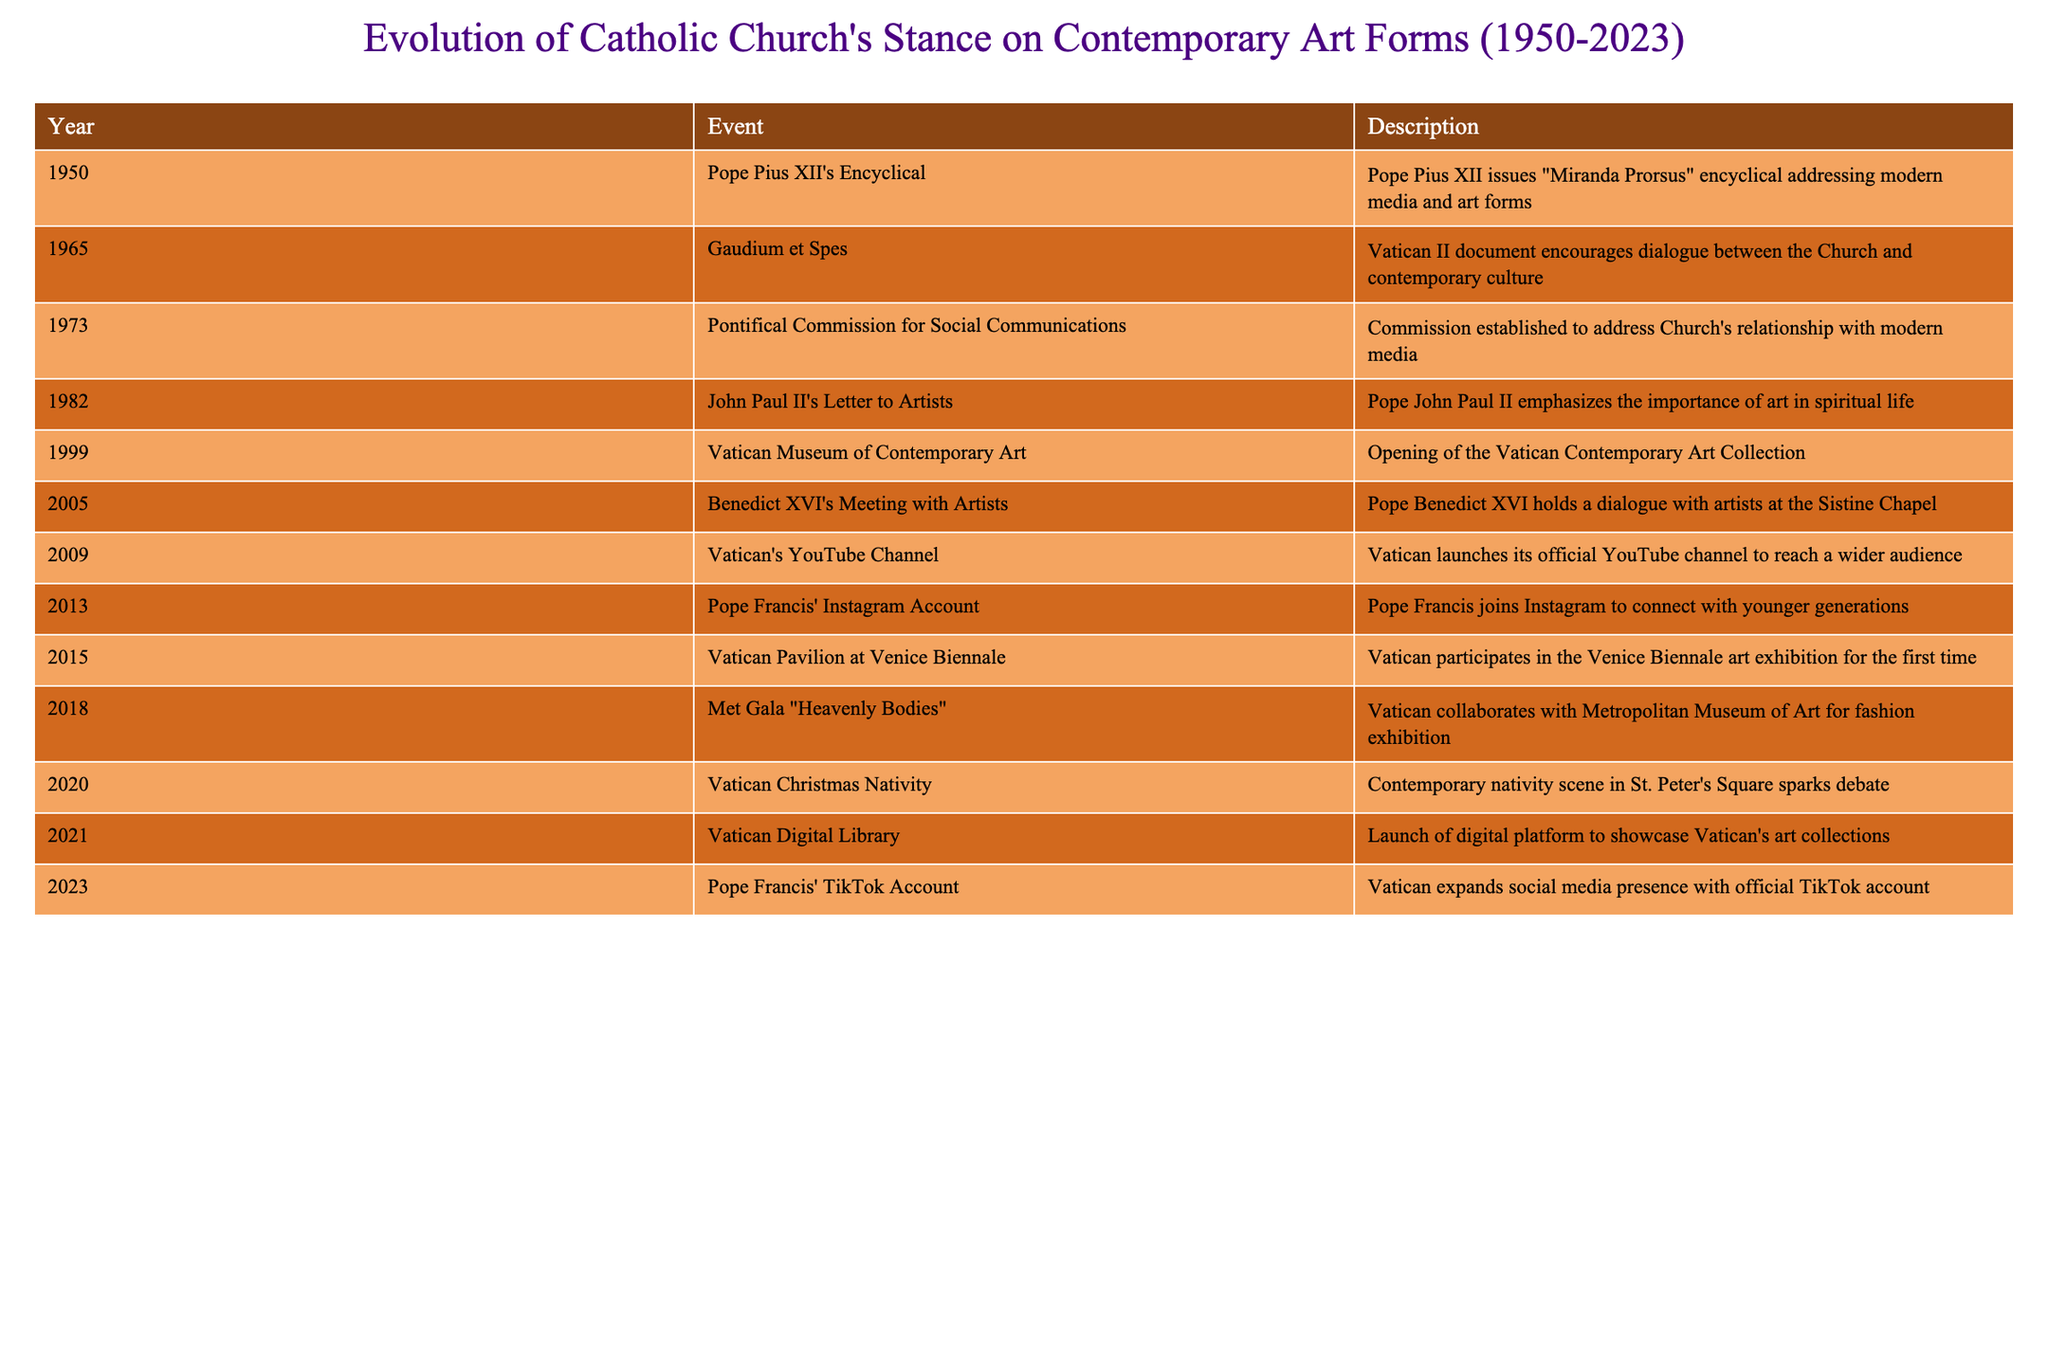What year did Pope Pius XII issue the encyclical addressing modern media and art forms? According to the table, Pope Pius XII issued the encyclical "Miranda Prorsus" in 1950.
Answer: 1950 Which Pope emphasized the importance of art in spiritual life in 1982? The table indicates that in 1982, Pope John Paul II emphasized the importance of art in spiritual life through his letter to artists.
Answer: Pope John Paul II Did the Vatican participate in the Venice Biennale art exhibition before 2015? The table shows that the Vatican participated in the Venice Biennale art exhibition for the first time in 2015, indicating that they did not participate before that year.
Answer: No How many events related to the Catholic Church's stance on contemporary art occurred between 2000 and 2020? By counting the entries in the table for the years 2000 to 2020, I see there are six events: 2005, 2009, 2013, 2015, 2018, and 2020. Thus, the total is 6 events.
Answer: 6 What was the significance of the Vatican's YouTube channel launched in 2009? The table states that the Vatican launched its official YouTube channel in 2009 to reach a wider audience, which marked a significant step towards engaging with modern media.
Answer: To reach a wider audience Combine the years from the events initiated by Popes John Paul II and Benedict XVI, what year did these two events occur? Pope John Paul II's letter to artists was issued in 1982 and Benedict XVI met with artists in 2005. Therefore, combining these years results in the years 1982 and 2005.
Answer: 1982 and 2005 